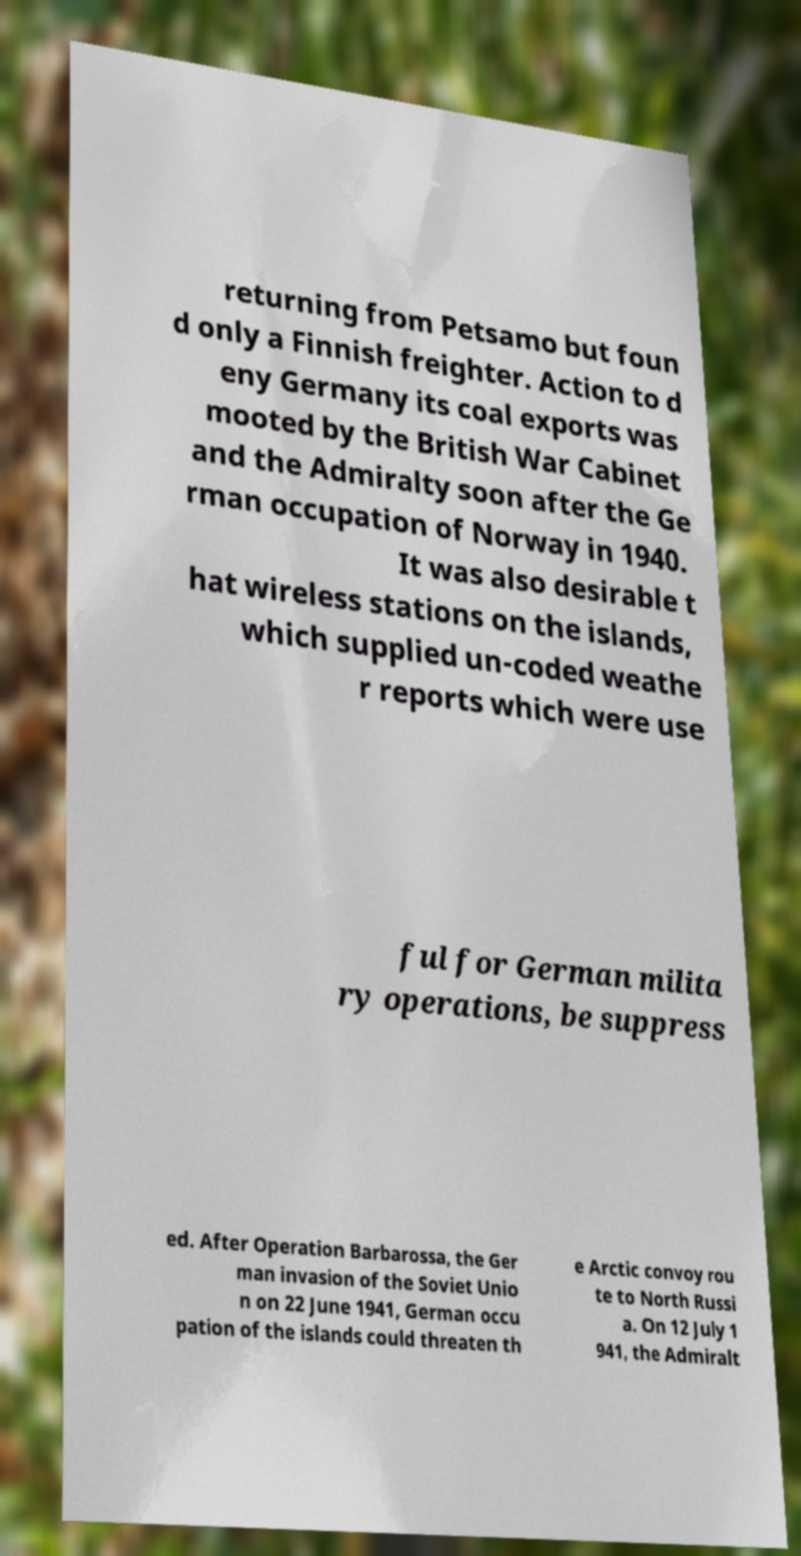Please identify and transcribe the text found in this image. returning from Petsamo but foun d only a Finnish freighter. Action to d eny Germany its coal exports was mooted by the British War Cabinet and the Admiralty soon after the Ge rman occupation of Norway in 1940. It was also desirable t hat wireless stations on the islands, which supplied un-coded weathe r reports which were use ful for German milita ry operations, be suppress ed. After Operation Barbarossa, the Ger man invasion of the Soviet Unio n on 22 June 1941, German occu pation of the islands could threaten th e Arctic convoy rou te to North Russi a. On 12 July 1 941, the Admiralt 